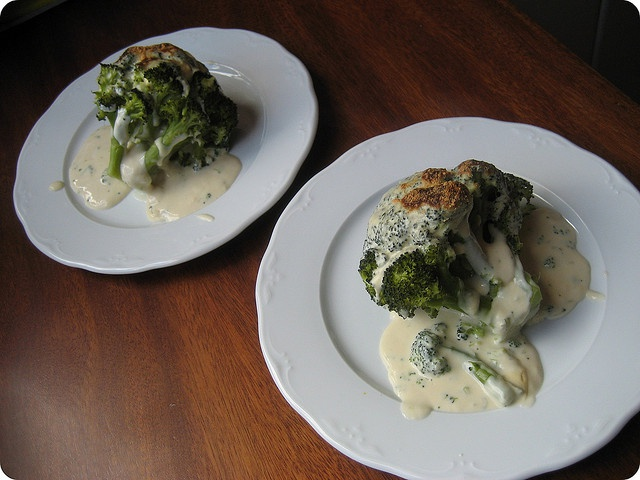Describe the objects in this image and their specific colors. I can see dining table in darkgray, black, maroon, white, and gray tones, broccoli in white, black, gray, darkgreen, and darkgray tones, broccoli in white, black, darkgreen, and gray tones, and broccoli in white, gray, darkgray, and darkgreen tones in this image. 